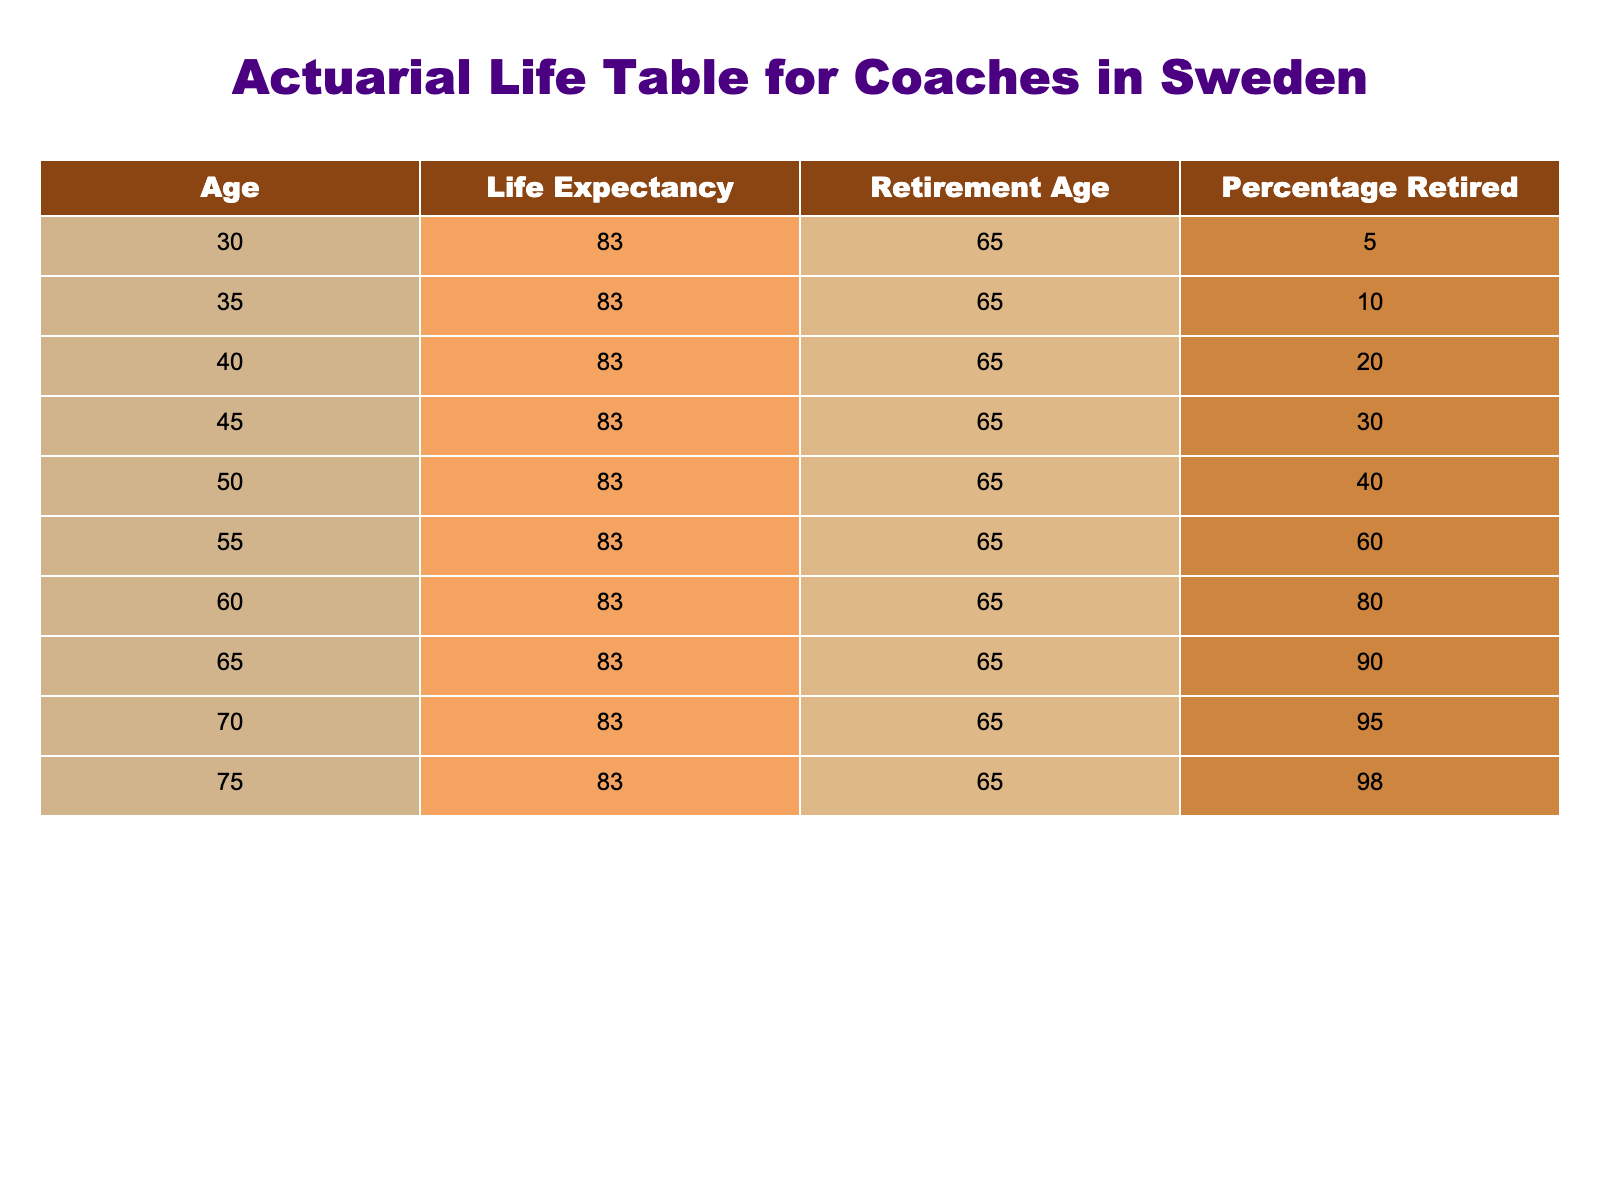What is the life expectancy for coaches in Sweden? According to the table, the life expectancy for all ages listed is shown to be 83. This figure is consistent across all age groups in the data.
Answer: 83 At what age does the percentage of retired coaches exceed 80%? By examining the "Percentage Retired" column, we see that the percentage exceeds 80 starting from age 60, where it is 80. At ages 65, 70, and 75, the percentages are 90, 95, and 98 respectively, all exceeding 80%.
Answer: 60 What is the retirement age indicated in the table? The table clearly states the retirement age for coaches in Sweden, which is listed as 65 years across all age groups.
Answer: 65 Calculate the average percentage of retired coaches between the ages of 30 and 50. To find the average percentage of retired coaches aged 30, 35, 40, 45, and 50, we first sum the percentages: 5 + 10 + 20 + 30 + 40 = 105. There are 5 age groups, so the average percentage is 105 / 5 = 21.
Answer: 21 Is it true that more than 90% of coaches are retired by the age of 70? Looking at the "Percentage Retired" for age 70, it shows 95%. Since 95% is indeed greater than 90%, the statement is true based on the data provided.
Answer: Yes Which age group has the highest percentage of retired coaches? Since the "Percentage Retired" increases with age, the age group with the highest percentage of retired coaches is 75, which has a percentage of 98.
Answer: 75 What's the life expectancy for coaches who retire at the age of 55? Referring back to the "Life Expectancy" column, we see that, regardless of retirement age, all listed ages have a life expectancy of 83. Thus, the life expectancy for coaches retiring at 55 is no different.
Answer: 83 What is the difference in retirement percentages between age 45 and age 55? To find the difference, we subtract the percentage of retirees aged 45 from that of those aged 55: 60 (age 55) - 30 (age 45) = 30. Therefore, the difference is 30 percentage points.
Answer: 30 At what age do 100% of coaches retire according to the data? The data does not indicate any age where 100% of coaches are reported to be retired, as the highest percentage listed is 98% at age 75. Thus, no age reaches a full 100% retirement ratio.
Answer: No 